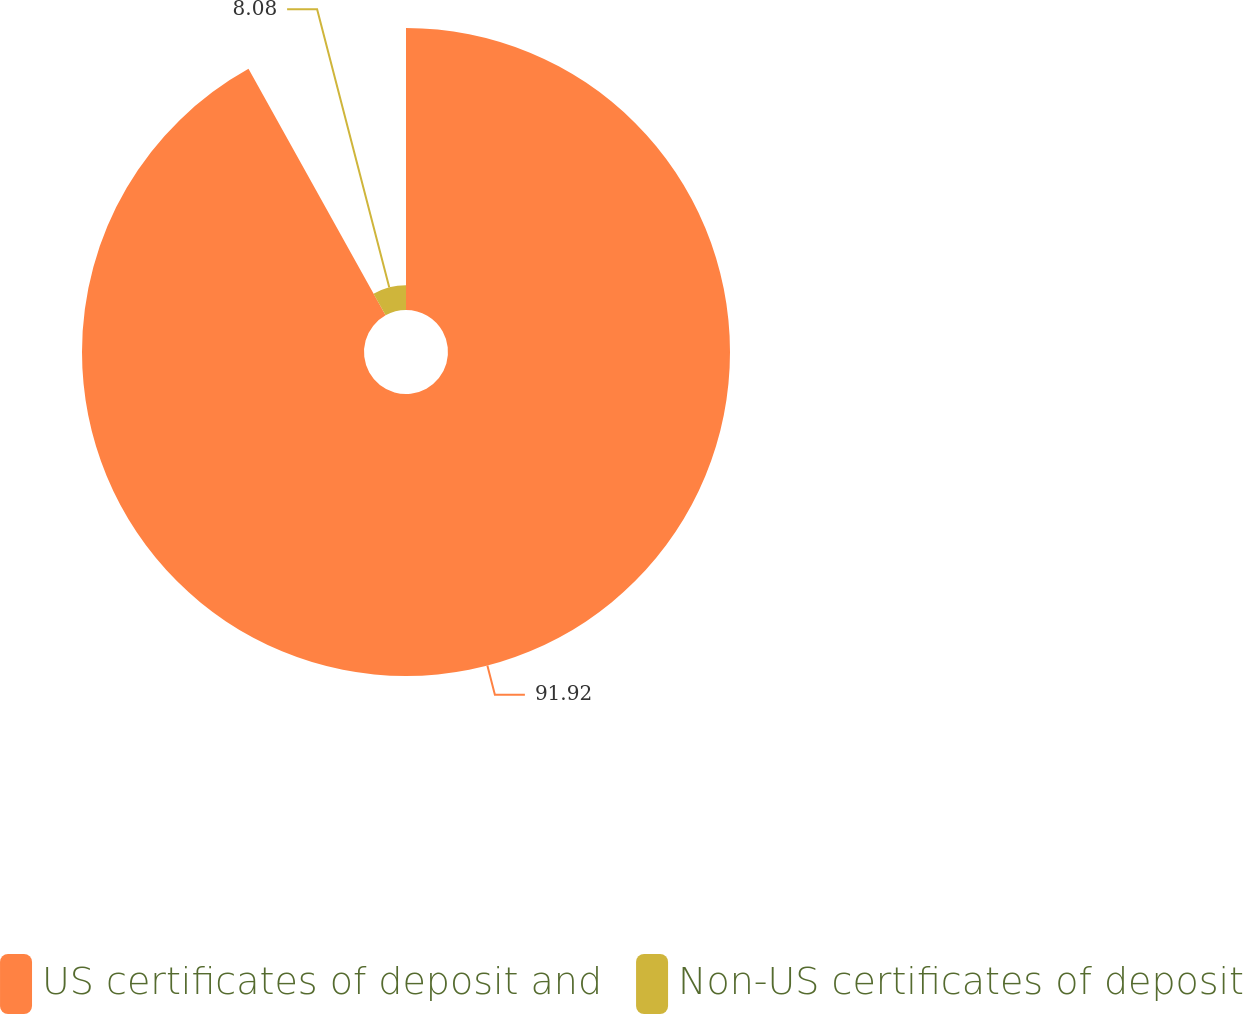Convert chart. <chart><loc_0><loc_0><loc_500><loc_500><pie_chart><fcel>US certificates of deposit and<fcel>Non-US certificates of deposit<nl><fcel>91.92%<fcel>8.08%<nl></chart> 